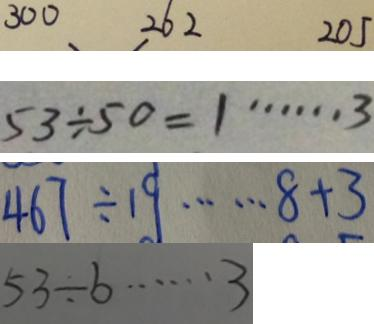Convert formula to latex. <formula><loc_0><loc_0><loc_500><loc_500>3 0 0 2 6 2 2 0 5 
 5 3 \div 5 0 = 1 \cdots 3 
 4 6 7 \div 1 9 \cdots 8 + 3 
 5 3 \div b \cdots 3</formula> 